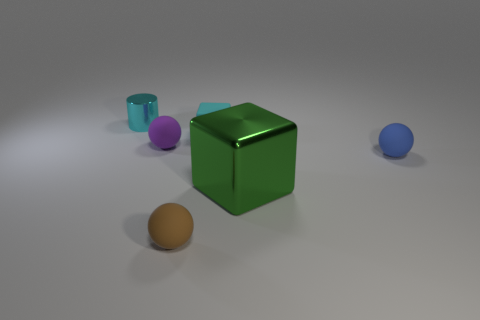Do the large green metal object and the purple thing have the same shape? no 